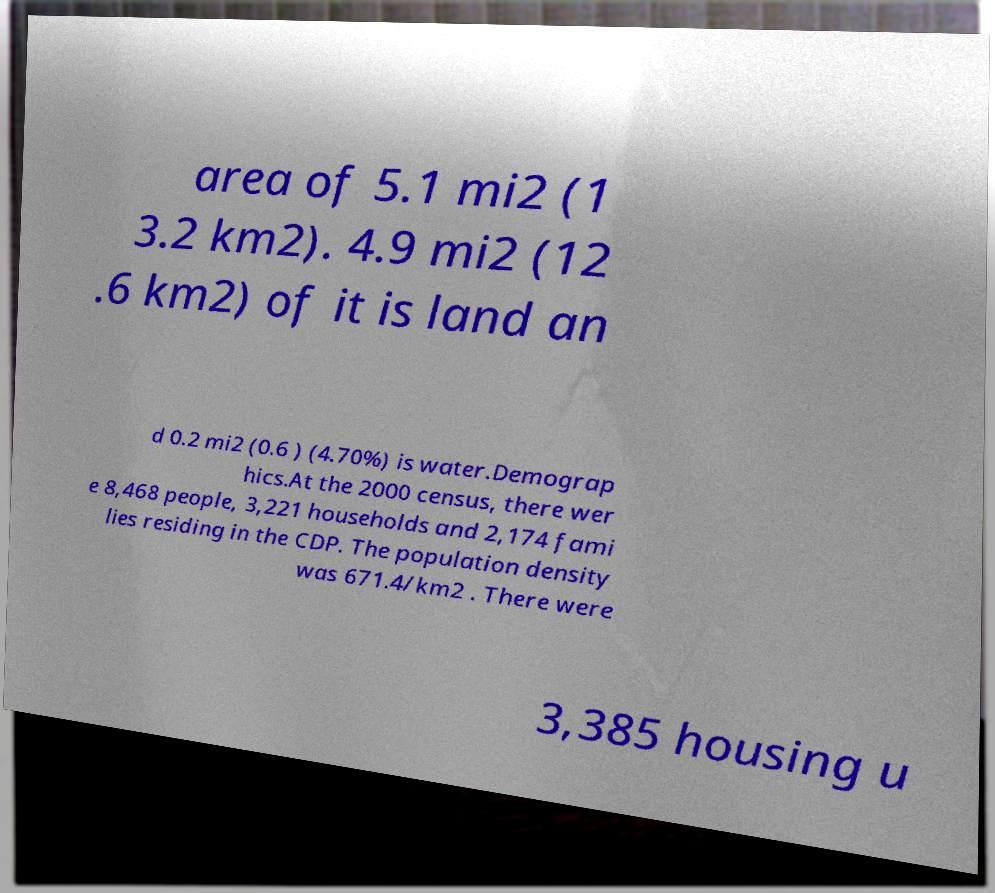What messages or text are displayed in this image? I need them in a readable, typed format. area of 5.1 mi2 (1 3.2 km2). 4.9 mi2 (12 .6 km2) of it is land an d 0.2 mi2 (0.6 ) (4.70%) is water.Demograp hics.At the 2000 census, there wer e 8,468 people, 3,221 households and 2,174 fami lies residing in the CDP. The population density was 671.4/km2 . There were 3,385 housing u 